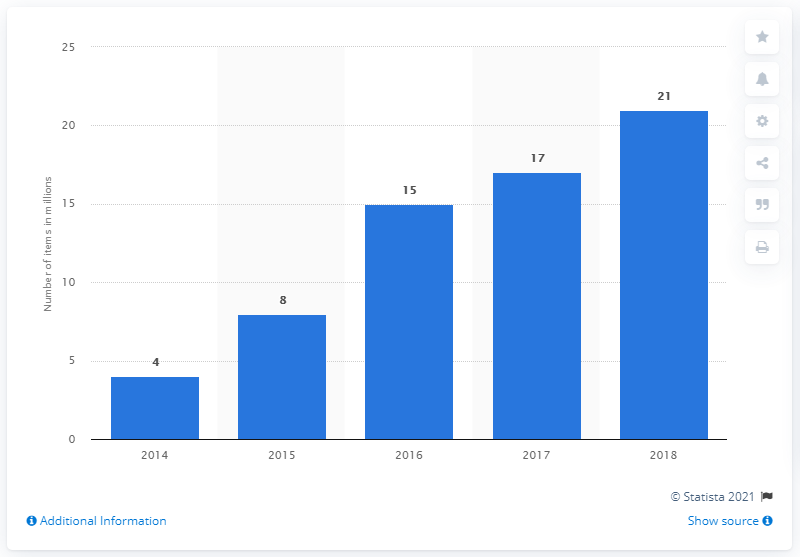Point out several critical features in this image. In 2018, 21 items were sent to ThredUp. In 2014, 21 items were sent to ThredUp. 